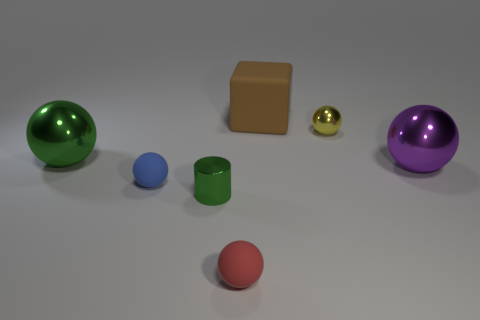Subtract 2 balls. How many balls are left? 3 Subtract all green spheres. How many spheres are left? 4 Subtract all purple balls. How many balls are left? 4 Add 1 cylinders. How many objects exist? 8 Subtract all purple balls. Subtract all purple cylinders. How many balls are left? 4 Subtract all cylinders. How many objects are left? 6 Subtract 0 gray balls. How many objects are left? 7 Subtract all large shiny blocks. Subtract all small red objects. How many objects are left? 6 Add 1 purple balls. How many purple balls are left? 2 Add 6 big purple things. How many big purple things exist? 7 